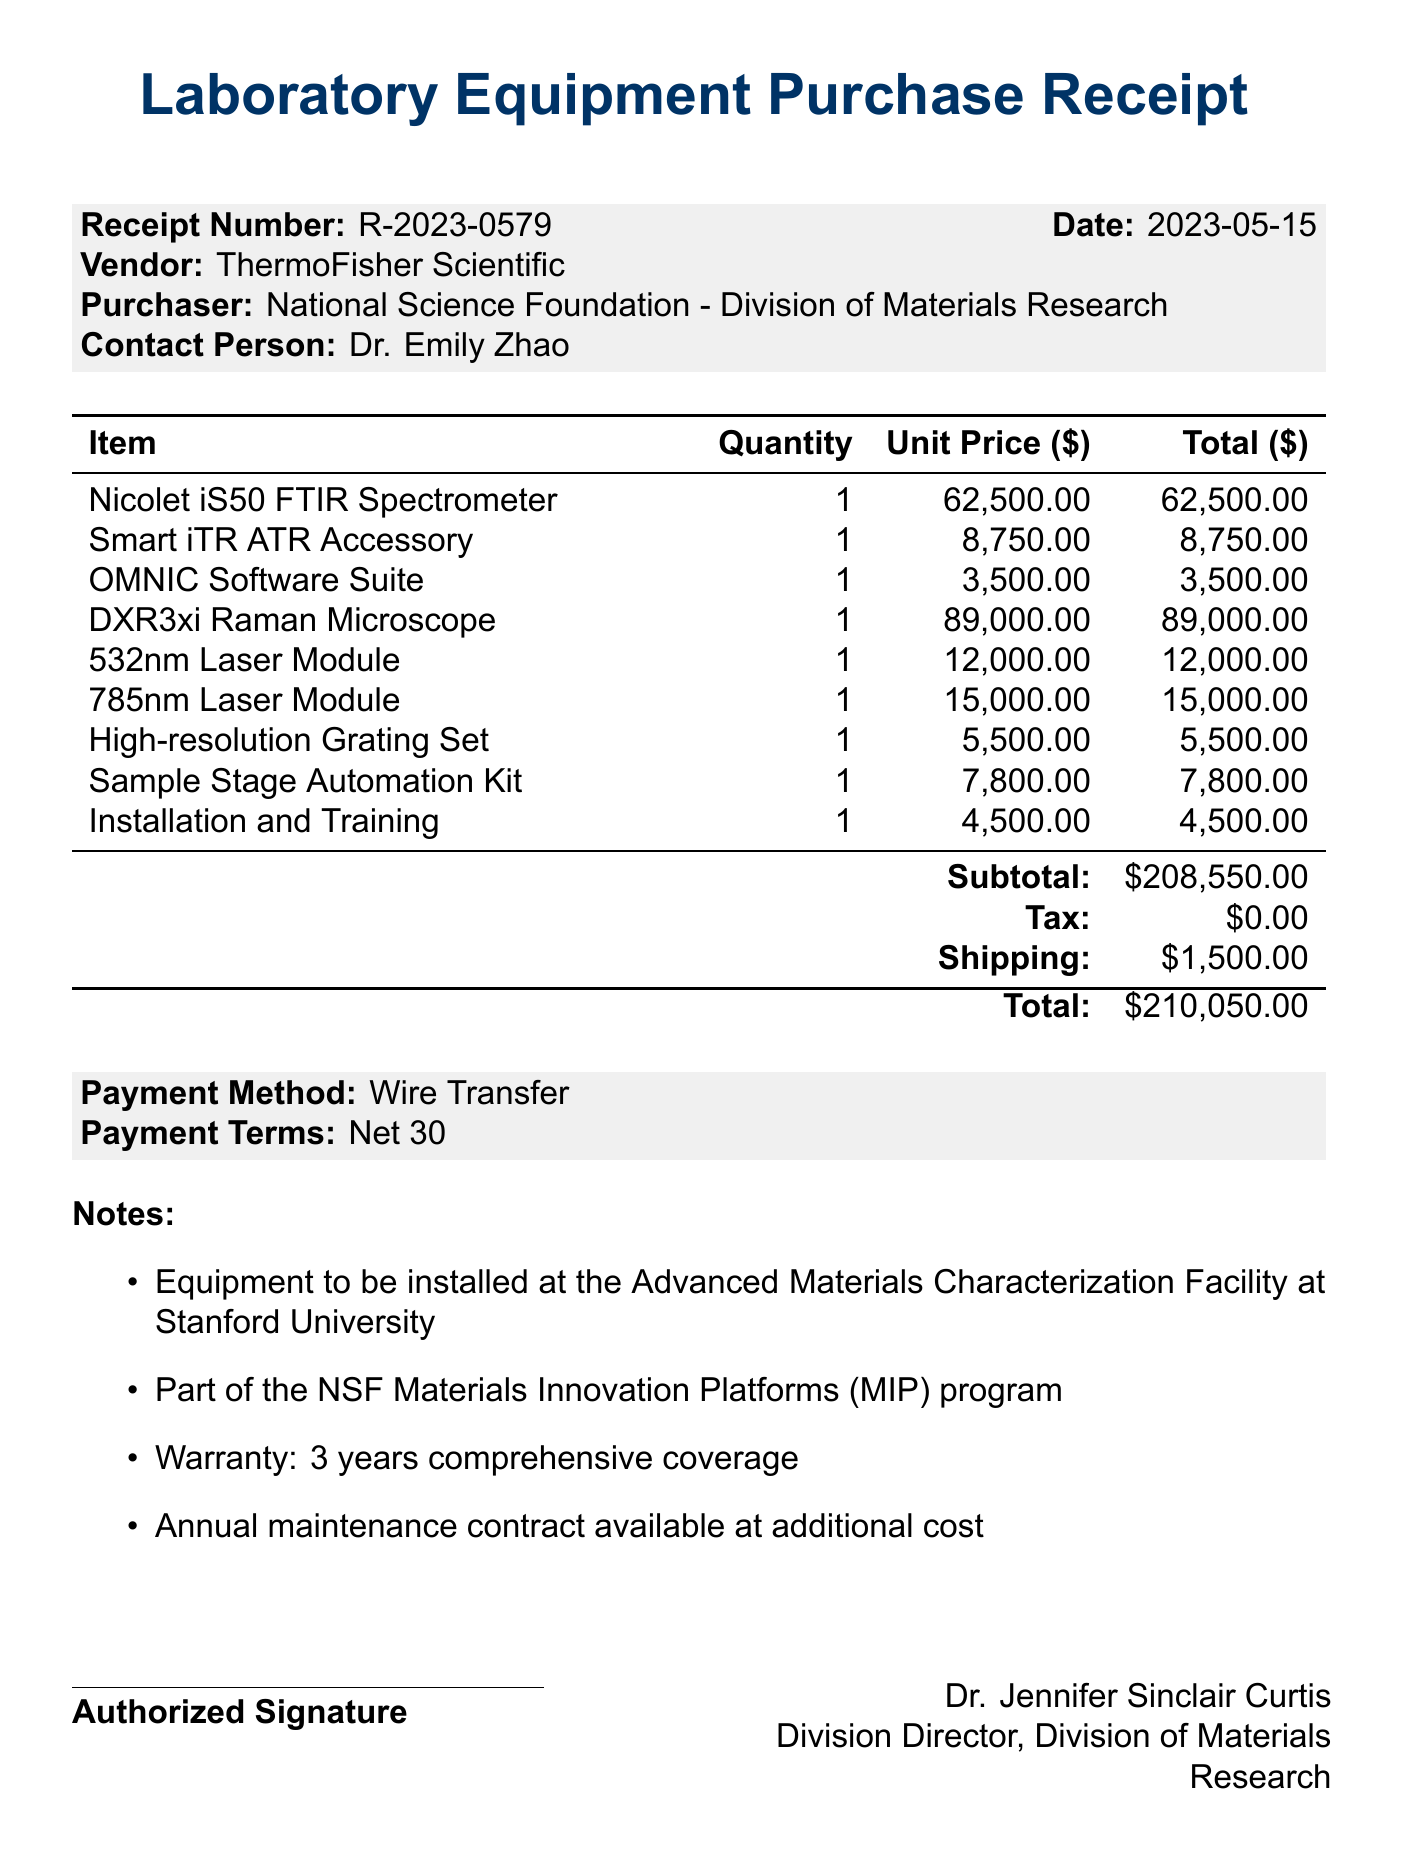What is the receipt number? The receipt number is a unique identifier for the transaction, provided in the document.
Answer: R-2023-0579 Who is the vendor? The vendor is the company or organization providing the items, specified in the document.
Answer: ThermoFisher Scientific What is the total cost of all items? The total cost is derived from the subtotal, tax, and shipping mentioned in the document.
Answer: 210050.00 How many items were purchased? The number of items can be determined by counting the individual components listed in the document.
Answer: 9 What is the unit price of the Nicolet iS50 FTIR Spectrometer? The unit price is the cost per item for the Nicolet iS50 FTIR Spectrometer, as stated in the document.
Answer: 62500.00 What payment method is used? The payment method outlines how the payment is made for the purchased items, provided in the document.
Answer: Wire Transfer In which facility is the equipment to be installed? The facility refers to the specific location where the equipment will be set up, mentioned in the notes section.
Answer: Advanced Materials Characterization Facility at Stanford University What is the warranty period for the equipment? The warranty period indicates the duration of coverage provided for the equipment, detailed in the notes.
Answer: 3 years Who authorized the purchase? The person who signed off on the receipt as part of the approval process is identified in the document.
Answer: Dr. Jennifer Sinclair Curtis 